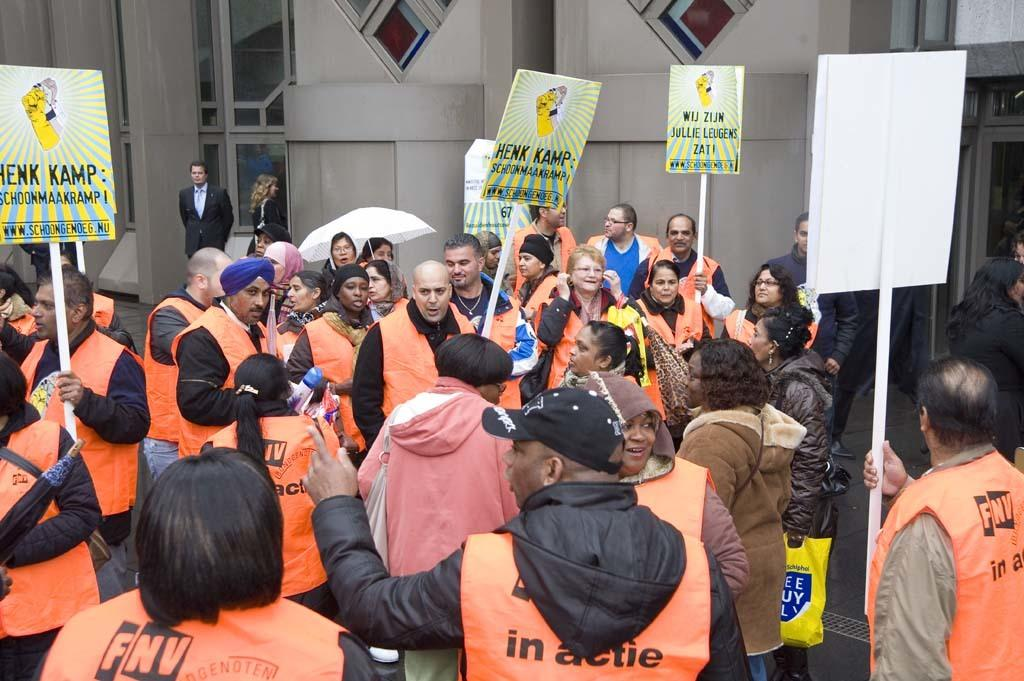<image>
Write a terse but informative summary of the picture. a protest led by people in orange jackets, signs reading hank kamp in their hands 